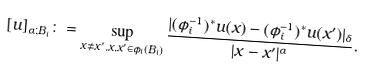Convert formula to latex. <formula><loc_0><loc_0><loc_500><loc_500>[ u ] _ { \alpha ; B _ { i } } \colon = \sup _ { x \neq x ^ { \prime } , x , x ^ { \prime } \in \phi _ { i } ( B _ { i } ) } \frac { | ( \phi _ { i } ^ { - 1 } ) ^ { * } u ( x ) - ( \phi _ { i } ^ { - 1 } ) ^ { * } u ( x ^ { \prime } ) | _ { \delta } } { | x - x ^ { \prime } | ^ { \alpha } } .</formula> 